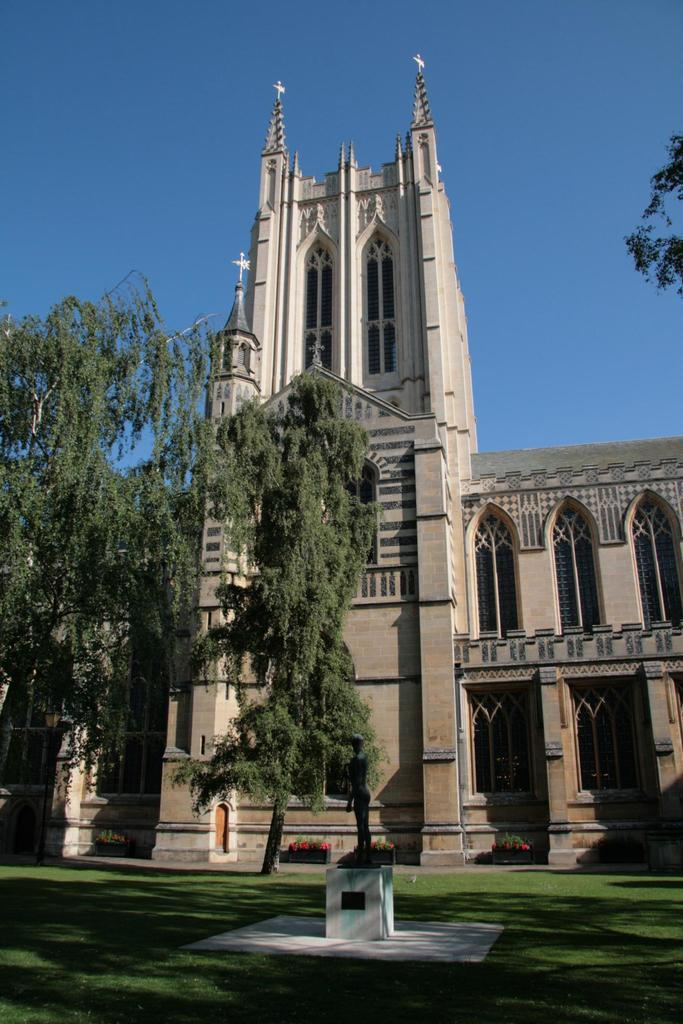What type of vegetation is in front of the building in the image? There are trees in front of the building in the image. What is visible at the top of the image? There is a sky at the top of the image. Can you describe the branch in the image? There is a branch in the top right of the image. What type of turkey is being told a story by the grandfather in the image? There is no turkey, grandfather, or story present in the image. 